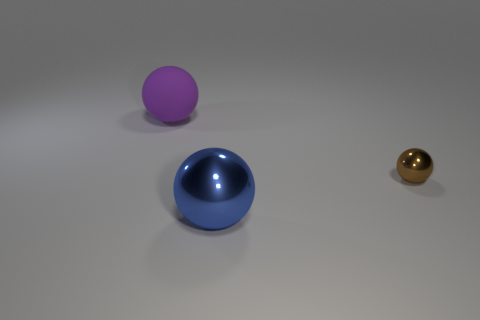What color is the sphere in front of the shiny sphere that is behind the big object that is in front of the big matte thing? The sphere in front of the shiny sphere, which is positioned behind the larger object near the front of the image, displays a rich blue hue. 